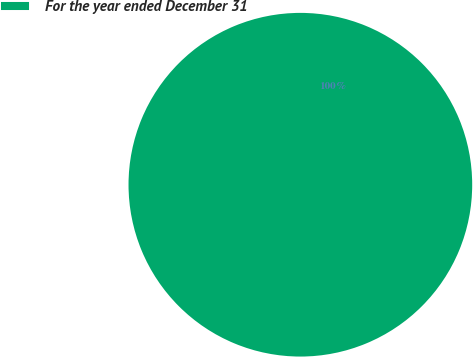Convert chart to OTSL. <chart><loc_0><loc_0><loc_500><loc_500><pie_chart><fcel>For the year ended December 31<nl><fcel>100.0%<nl></chart> 